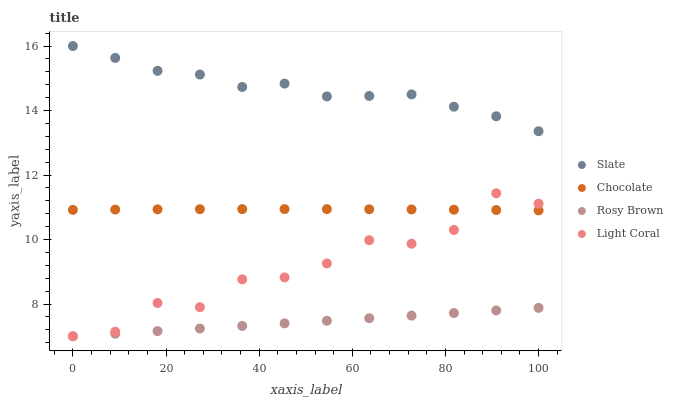Does Rosy Brown have the minimum area under the curve?
Answer yes or no. Yes. Does Slate have the maximum area under the curve?
Answer yes or no. Yes. Does Slate have the minimum area under the curve?
Answer yes or no. No. Does Rosy Brown have the maximum area under the curve?
Answer yes or no. No. Is Rosy Brown the smoothest?
Answer yes or no. Yes. Is Light Coral the roughest?
Answer yes or no. Yes. Is Slate the smoothest?
Answer yes or no. No. Is Slate the roughest?
Answer yes or no. No. Does Light Coral have the lowest value?
Answer yes or no. Yes. Does Slate have the lowest value?
Answer yes or no. No. Does Slate have the highest value?
Answer yes or no. Yes. Does Rosy Brown have the highest value?
Answer yes or no. No. Is Rosy Brown less than Slate?
Answer yes or no. Yes. Is Chocolate greater than Rosy Brown?
Answer yes or no. Yes. Does Chocolate intersect Light Coral?
Answer yes or no. Yes. Is Chocolate less than Light Coral?
Answer yes or no. No. Is Chocolate greater than Light Coral?
Answer yes or no. No. Does Rosy Brown intersect Slate?
Answer yes or no. No. 